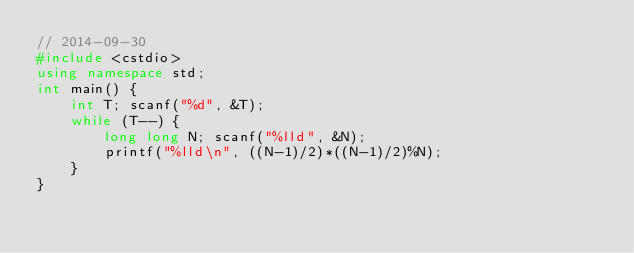<code> <loc_0><loc_0><loc_500><loc_500><_C++_>// 2014-09-30
#include <cstdio>
using namespace std;
int main() {
    int T; scanf("%d", &T);
    while (T--) {
        long long N; scanf("%lld", &N);
        printf("%lld\n", ((N-1)/2)*((N-1)/2)%N);
    }
}
</code> 